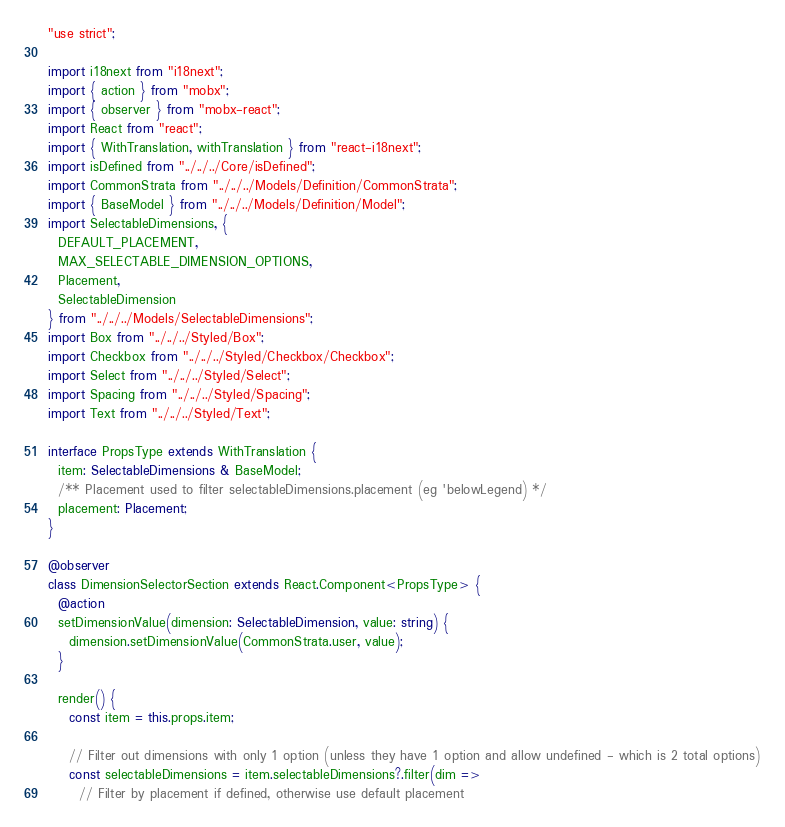<code> <loc_0><loc_0><loc_500><loc_500><_TypeScript_>"use strict";

import i18next from "i18next";
import { action } from "mobx";
import { observer } from "mobx-react";
import React from "react";
import { WithTranslation, withTranslation } from "react-i18next";
import isDefined from "../../../Core/isDefined";
import CommonStrata from "../../../Models/Definition/CommonStrata";
import { BaseModel } from "../../../Models/Definition/Model";
import SelectableDimensions, {
  DEFAULT_PLACEMENT,
  MAX_SELECTABLE_DIMENSION_OPTIONS,
  Placement,
  SelectableDimension
} from "../../../Models/SelectableDimensions";
import Box from "../../../Styled/Box";
import Checkbox from "../../../Styled/Checkbox/Checkbox";
import Select from "../../../Styled/Select";
import Spacing from "../../../Styled/Spacing";
import Text from "../../../Styled/Text";

interface PropsType extends WithTranslation {
  item: SelectableDimensions & BaseModel;
  /** Placement used to filter selectableDimensions.placement (eg 'belowLegend) */
  placement: Placement;
}

@observer
class DimensionSelectorSection extends React.Component<PropsType> {
  @action
  setDimensionValue(dimension: SelectableDimension, value: string) {
    dimension.setDimensionValue(CommonStrata.user, value);
  }

  render() {
    const item = this.props.item;

    // Filter out dimensions with only 1 option (unless they have 1 option and allow undefined - which is 2 total options)
    const selectableDimensions = item.selectableDimensions?.filter(dim =>
      // Filter by placement if defined, otherwise use default placement</code> 